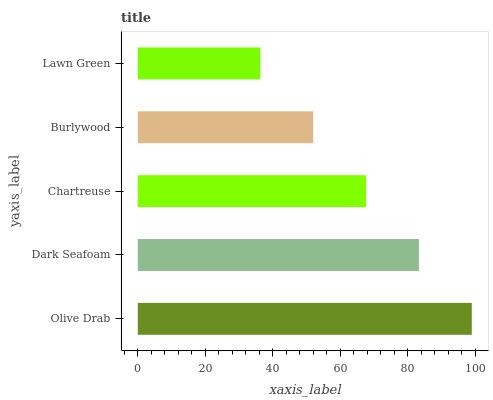Is Lawn Green the minimum?
Answer yes or no. Yes. Is Olive Drab the maximum?
Answer yes or no. Yes. Is Dark Seafoam the minimum?
Answer yes or no. No. Is Dark Seafoam the maximum?
Answer yes or no. No. Is Olive Drab greater than Dark Seafoam?
Answer yes or no. Yes. Is Dark Seafoam less than Olive Drab?
Answer yes or no. Yes. Is Dark Seafoam greater than Olive Drab?
Answer yes or no. No. Is Olive Drab less than Dark Seafoam?
Answer yes or no. No. Is Chartreuse the high median?
Answer yes or no. Yes. Is Chartreuse the low median?
Answer yes or no. Yes. Is Lawn Green the high median?
Answer yes or no. No. Is Lawn Green the low median?
Answer yes or no. No. 